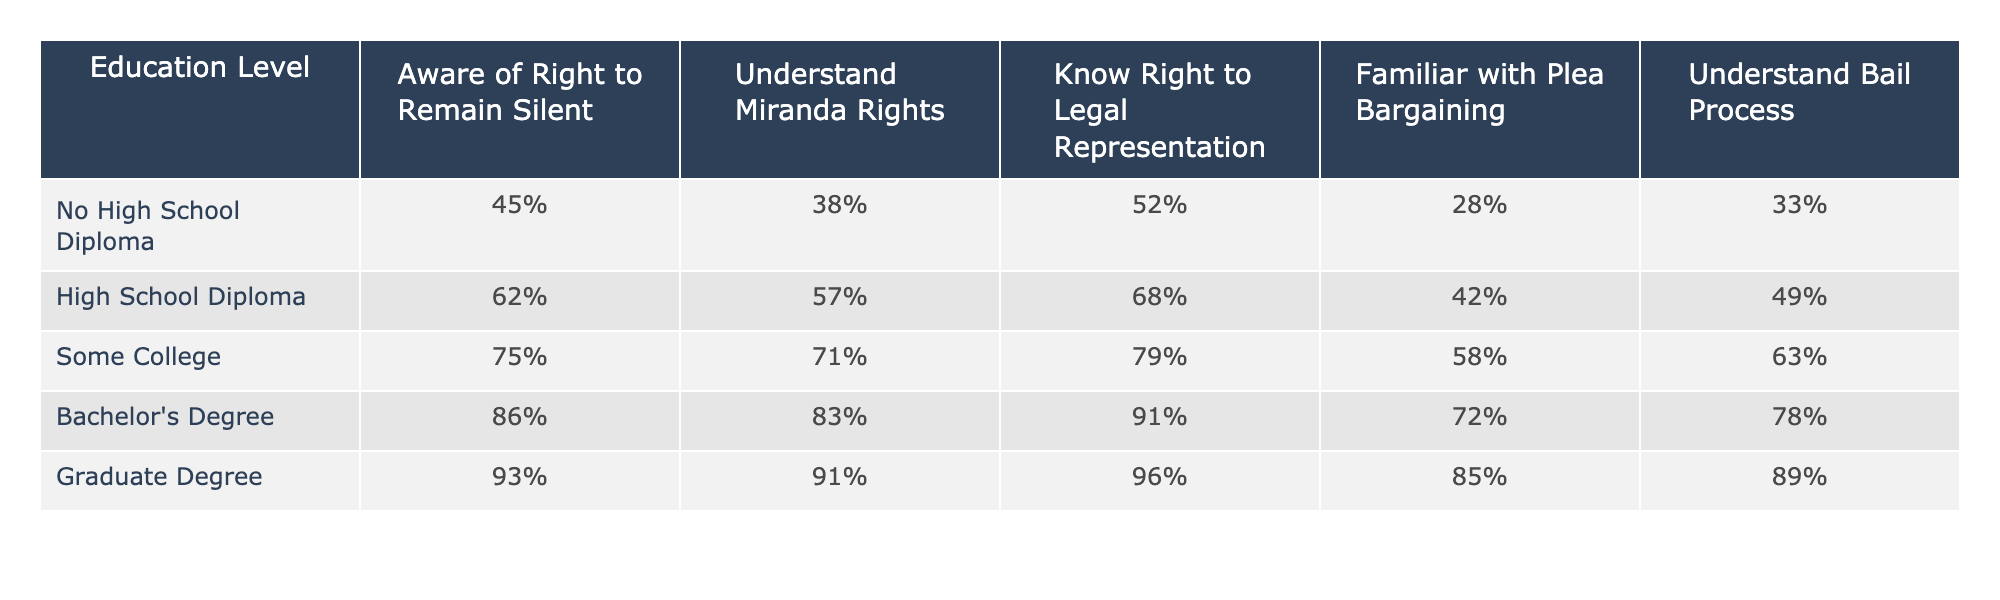What is the percentage of people with a Bachelor's Degree who are aware of their right to remain silent? Looking at the "Bachelor's Degree" row in the table, the percentage for "Aware of Right to Remain Silent" is 86%.
Answer: 86% Which education level has the lowest understanding of Miranda Rights? By comparing the percentages listed under "Understand Miranda Rights," it's clear that "No High School Diploma" has the lowest at 38%.
Answer: No High School Diploma What is the difference in the percentage of knowledge about the Right to Legal Representation between those with a Graduate Degree and those with a High School Diploma? The percentage for graduates is 96% and for high school diploma holders it's 68%. The difference is 96 - 68 = 28%.
Answer: 28% Is it true that individuals with some college education are more familiar with plea bargaining than those with a Bachelor's Degree? Checking the respective rows, "Some College" has 58% familiarity with plea bargaining, while "Bachelor's Degree" has 72%. Since 58% < 72%, the statement is false.
Answer: No What is the average percentage of awareness for "Know Right to Legal Representation" among all education levels? The percentages for awareness under this category are 52%, 68%, 79%, 91%, and 96%. To find the average: (52 + 68 + 79 + 91 + 96) / 5 = 77.2%.
Answer: 77.2% Which group shows the highest percentage of understanding the Bail Process? The highest percentage for "Understand Bail Process" is found in the "Graduate Degree" row at 89%.
Answer: Graduate Degree How much more likely is someone with a Graduate Degree to be aware of their right to remain silent compared to someone with no high school diploma? The percentage for those with a Graduate Degree is 93% and for those with no high school diploma, it is 45%. The difference is 93 - 45 = 48%.
Answer: 48% Are people with a Bachelor's Degree more aware of their right to remain silent than those with some college education? The Bachelor's Degree percentage is 86%, and for some college, it is 75%. Since 86% > 75%, it is true that Bachelor's Degree holders are more aware.
Answer: Yes What percentage of individuals with a No High School Diploma are familiar with the plea bargaining process? Referring to the "No High School Diploma" row, the familiarity percentage for plea bargaining is 28%.
Answer: 28% If we consider only those with a high school diploma and those with a graduate degree, what is the combined percentage of those who understand the bail process? The percentages are 49% for high school diploma holders and 89% for graduates. The combined percentage is 49 + 89 = 138%.
Answer: 138% 